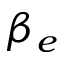Convert formula to latex. <formula><loc_0><loc_0><loc_500><loc_500>\beta _ { e }</formula> 